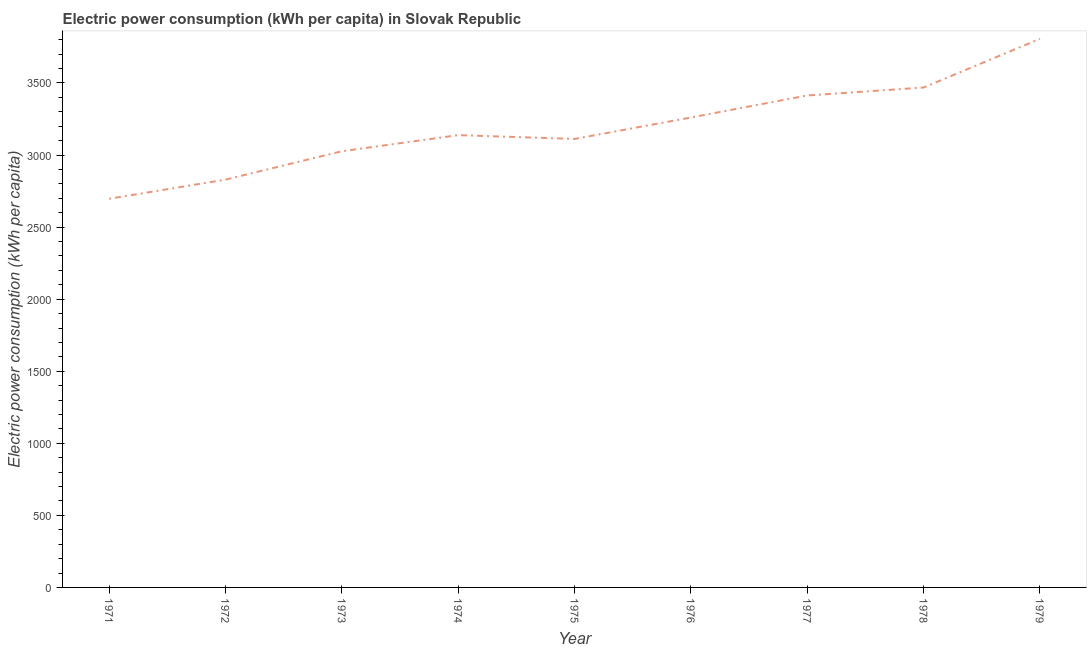What is the electric power consumption in 1971?
Ensure brevity in your answer.  2696.68. Across all years, what is the maximum electric power consumption?
Keep it short and to the point. 3806.46. Across all years, what is the minimum electric power consumption?
Offer a terse response. 2696.68. In which year was the electric power consumption maximum?
Offer a very short reply. 1979. What is the sum of the electric power consumption?
Your answer should be compact. 2.88e+04. What is the difference between the electric power consumption in 1973 and 1975?
Make the answer very short. -85.56. What is the average electric power consumption per year?
Your answer should be very brief. 3194.6. What is the median electric power consumption?
Your answer should be compact. 3138.21. Do a majority of the years between 1972 and 1978 (inclusive) have electric power consumption greater than 1900 kWh per capita?
Provide a short and direct response. Yes. What is the ratio of the electric power consumption in 1977 to that in 1978?
Offer a terse response. 0.98. What is the difference between the highest and the second highest electric power consumption?
Ensure brevity in your answer.  337.84. Is the sum of the electric power consumption in 1972 and 1979 greater than the maximum electric power consumption across all years?
Ensure brevity in your answer.  Yes. What is the difference between the highest and the lowest electric power consumption?
Offer a terse response. 1109.78. How many lines are there?
Make the answer very short. 1. What is the difference between two consecutive major ticks on the Y-axis?
Give a very brief answer. 500. Are the values on the major ticks of Y-axis written in scientific E-notation?
Your response must be concise. No. Does the graph contain any zero values?
Your answer should be very brief. No. Does the graph contain grids?
Give a very brief answer. No. What is the title of the graph?
Your answer should be compact. Electric power consumption (kWh per capita) in Slovak Republic. What is the label or title of the Y-axis?
Ensure brevity in your answer.  Electric power consumption (kWh per capita). What is the Electric power consumption (kWh per capita) of 1971?
Give a very brief answer. 2696.68. What is the Electric power consumption (kWh per capita) in 1972?
Ensure brevity in your answer.  2829.47. What is the Electric power consumption (kWh per capita) in 1973?
Offer a very short reply. 3026.21. What is the Electric power consumption (kWh per capita) of 1974?
Make the answer very short. 3138.21. What is the Electric power consumption (kWh per capita) in 1975?
Offer a very short reply. 3111.77. What is the Electric power consumption (kWh per capita) in 1976?
Your response must be concise. 3260.46. What is the Electric power consumption (kWh per capita) in 1977?
Give a very brief answer. 3413.49. What is the Electric power consumption (kWh per capita) in 1978?
Give a very brief answer. 3468.62. What is the Electric power consumption (kWh per capita) of 1979?
Keep it short and to the point. 3806.46. What is the difference between the Electric power consumption (kWh per capita) in 1971 and 1972?
Offer a very short reply. -132.79. What is the difference between the Electric power consumption (kWh per capita) in 1971 and 1973?
Your answer should be compact. -329.53. What is the difference between the Electric power consumption (kWh per capita) in 1971 and 1974?
Give a very brief answer. -441.52. What is the difference between the Electric power consumption (kWh per capita) in 1971 and 1975?
Make the answer very short. -415.08. What is the difference between the Electric power consumption (kWh per capita) in 1971 and 1976?
Provide a short and direct response. -563.78. What is the difference between the Electric power consumption (kWh per capita) in 1971 and 1977?
Make the answer very short. -716.81. What is the difference between the Electric power consumption (kWh per capita) in 1971 and 1978?
Your answer should be very brief. -771.94. What is the difference between the Electric power consumption (kWh per capita) in 1971 and 1979?
Offer a very short reply. -1109.78. What is the difference between the Electric power consumption (kWh per capita) in 1972 and 1973?
Your answer should be compact. -196.74. What is the difference between the Electric power consumption (kWh per capita) in 1972 and 1974?
Ensure brevity in your answer.  -308.74. What is the difference between the Electric power consumption (kWh per capita) in 1972 and 1975?
Your answer should be compact. -282.3. What is the difference between the Electric power consumption (kWh per capita) in 1972 and 1976?
Provide a short and direct response. -430.99. What is the difference between the Electric power consumption (kWh per capita) in 1972 and 1977?
Ensure brevity in your answer.  -584.02. What is the difference between the Electric power consumption (kWh per capita) in 1972 and 1978?
Ensure brevity in your answer.  -639.15. What is the difference between the Electric power consumption (kWh per capita) in 1972 and 1979?
Provide a short and direct response. -976.99. What is the difference between the Electric power consumption (kWh per capita) in 1973 and 1974?
Ensure brevity in your answer.  -111.99. What is the difference between the Electric power consumption (kWh per capita) in 1973 and 1975?
Keep it short and to the point. -85.56. What is the difference between the Electric power consumption (kWh per capita) in 1973 and 1976?
Offer a very short reply. -234.25. What is the difference between the Electric power consumption (kWh per capita) in 1973 and 1977?
Give a very brief answer. -387.28. What is the difference between the Electric power consumption (kWh per capita) in 1973 and 1978?
Offer a very short reply. -442.41. What is the difference between the Electric power consumption (kWh per capita) in 1973 and 1979?
Provide a succinct answer. -780.25. What is the difference between the Electric power consumption (kWh per capita) in 1974 and 1975?
Make the answer very short. 26.44. What is the difference between the Electric power consumption (kWh per capita) in 1974 and 1976?
Offer a terse response. -122.26. What is the difference between the Electric power consumption (kWh per capita) in 1974 and 1977?
Ensure brevity in your answer.  -275.28. What is the difference between the Electric power consumption (kWh per capita) in 1974 and 1978?
Ensure brevity in your answer.  -330.42. What is the difference between the Electric power consumption (kWh per capita) in 1974 and 1979?
Give a very brief answer. -668.25. What is the difference between the Electric power consumption (kWh per capita) in 1975 and 1976?
Offer a terse response. -148.69. What is the difference between the Electric power consumption (kWh per capita) in 1975 and 1977?
Give a very brief answer. -301.72. What is the difference between the Electric power consumption (kWh per capita) in 1975 and 1978?
Your response must be concise. -356.85. What is the difference between the Electric power consumption (kWh per capita) in 1975 and 1979?
Make the answer very short. -694.69. What is the difference between the Electric power consumption (kWh per capita) in 1976 and 1977?
Provide a short and direct response. -153.03. What is the difference between the Electric power consumption (kWh per capita) in 1976 and 1978?
Ensure brevity in your answer.  -208.16. What is the difference between the Electric power consumption (kWh per capita) in 1976 and 1979?
Your response must be concise. -546. What is the difference between the Electric power consumption (kWh per capita) in 1977 and 1978?
Provide a short and direct response. -55.13. What is the difference between the Electric power consumption (kWh per capita) in 1977 and 1979?
Your answer should be very brief. -392.97. What is the difference between the Electric power consumption (kWh per capita) in 1978 and 1979?
Provide a succinct answer. -337.84. What is the ratio of the Electric power consumption (kWh per capita) in 1971 to that in 1972?
Your response must be concise. 0.95. What is the ratio of the Electric power consumption (kWh per capita) in 1971 to that in 1973?
Your answer should be very brief. 0.89. What is the ratio of the Electric power consumption (kWh per capita) in 1971 to that in 1974?
Your response must be concise. 0.86. What is the ratio of the Electric power consumption (kWh per capita) in 1971 to that in 1975?
Give a very brief answer. 0.87. What is the ratio of the Electric power consumption (kWh per capita) in 1971 to that in 1976?
Provide a succinct answer. 0.83. What is the ratio of the Electric power consumption (kWh per capita) in 1971 to that in 1977?
Make the answer very short. 0.79. What is the ratio of the Electric power consumption (kWh per capita) in 1971 to that in 1978?
Ensure brevity in your answer.  0.78. What is the ratio of the Electric power consumption (kWh per capita) in 1971 to that in 1979?
Ensure brevity in your answer.  0.71. What is the ratio of the Electric power consumption (kWh per capita) in 1972 to that in 1973?
Make the answer very short. 0.94. What is the ratio of the Electric power consumption (kWh per capita) in 1972 to that in 1974?
Give a very brief answer. 0.9. What is the ratio of the Electric power consumption (kWh per capita) in 1972 to that in 1975?
Ensure brevity in your answer.  0.91. What is the ratio of the Electric power consumption (kWh per capita) in 1972 to that in 1976?
Keep it short and to the point. 0.87. What is the ratio of the Electric power consumption (kWh per capita) in 1972 to that in 1977?
Keep it short and to the point. 0.83. What is the ratio of the Electric power consumption (kWh per capita) in 1972 to that in 1978?
Keep it short and to the point. 0.82. What is the ratio of the Electric power consumption (kWh per capita) in 1972 to that in 1979?
Your answer should be compact. 0.74. What is the ratio of the Electric power consumption (kWh per capita) in 1973 to that in 1975?
Keep it short and to the point. 0.97. What is the ratio of the Electric power consumption (kWh per capita) in 1973 to that in 1976?
Provide a short and direct response. 0.93. What is the ratio of the Electric power consumption (kWh per capita) in 1973 to that in 1977?
Provide a short and direct response. 0.89. What is the ratio of the Electric power consumption (kWh per capita) in 1973 to that in 1978?
Give a very brief answer. 0.87. What is the ratio of the Electric power consumption (kWh per capita) in 1973 to that in 1979?
Keep it short and to the point. 0.8. What is the ratio of the Electric power consumption (kWh per capita) in 1974 to that in 1975?
Give a very brief answer. 1.01. What is the ratio of the Electric power consumption (kWh per capita) in 1974 to that in 1976?
Make the answer very short. 0.96. What is the ratio of the Electric power consumption (kWh per capita) in 1974 to that in 1977?
Provide a short and direct response. 0.92. What is the ratio of the Electric power consumption (kWh per capita) in 1974 to that in 1978?
Give a very brief answer. 0.91. What is the ratio of the Electric power consumption (kWh per capita) in 1974 to that in 1979?
Your answer should be compact. 0.82. What is the ratio of the Electric power consumption (kWh per capita) in 1975 to that in 1976?
Your response must be concise. 0.95. What is the ratio of the Electric power consumption (kWh per capita) in 1975 to that in 1977?
Offer a terse response. 0.91. What is the ratio of the Electric power consumption (kWh per capita) in 1975 to that in 1978?
Give a very brief answer. 0.9. What is the ratio of the Electric power consumption (kWh per capita) in 1975 to that in 1979?
Ensure brevity in your answer.  0.82. What is the ratio of the Electric power consumption (kWh per capita) in 1976 to that in 1977?
Ensure brevity in your answer.  0.95. What is the ratio of the Electric power consumption (kWh per capita) in 1976 to that in 1978?
Keep it short and to the point. 0.94. What is the ratio of the Electric power consumption (kWh per capita) in 1976 to that in 1979?
Your response must be concise. 0.86. What is the ratio of the Electric power consumption (kWh per capita) in 1977 to that in 1979?
Keep it short and to the point. 0.9. What is the ratio of the Electric power consumption (kWh per capita) in 1978 to that in 1979?
Your answer should be compact. 0.91. 